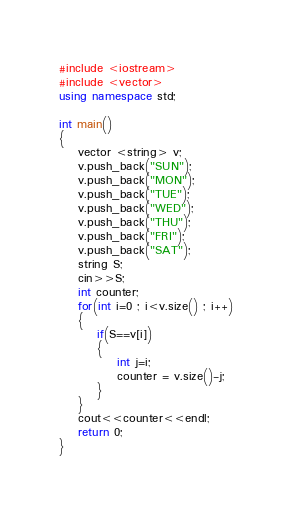Convert code to text. <code><loc_0><loc_0><loc_500><loc_500><_C++_>#include <iostream>
#include <vector>
using namespace std;

int main()
{
    vector <string> v;
    v.push_back("SUN");
    v.push_back("MON");
    v.push_back("TUE");
    v.push_back("WED");
    v.push_back("THU");
    v.push_back("FRI");
    v.push_back("SAT");
    string S;
    cin>>S;
    int counter;
    for(int i=0 ; i<v.size() ; i++)
    {
        if(S==v[i])
        {
            int j=i;
            counter = v.size()-j;
        }
    }
    cout<<counter<<endl;
    return 0;
}
</code> 